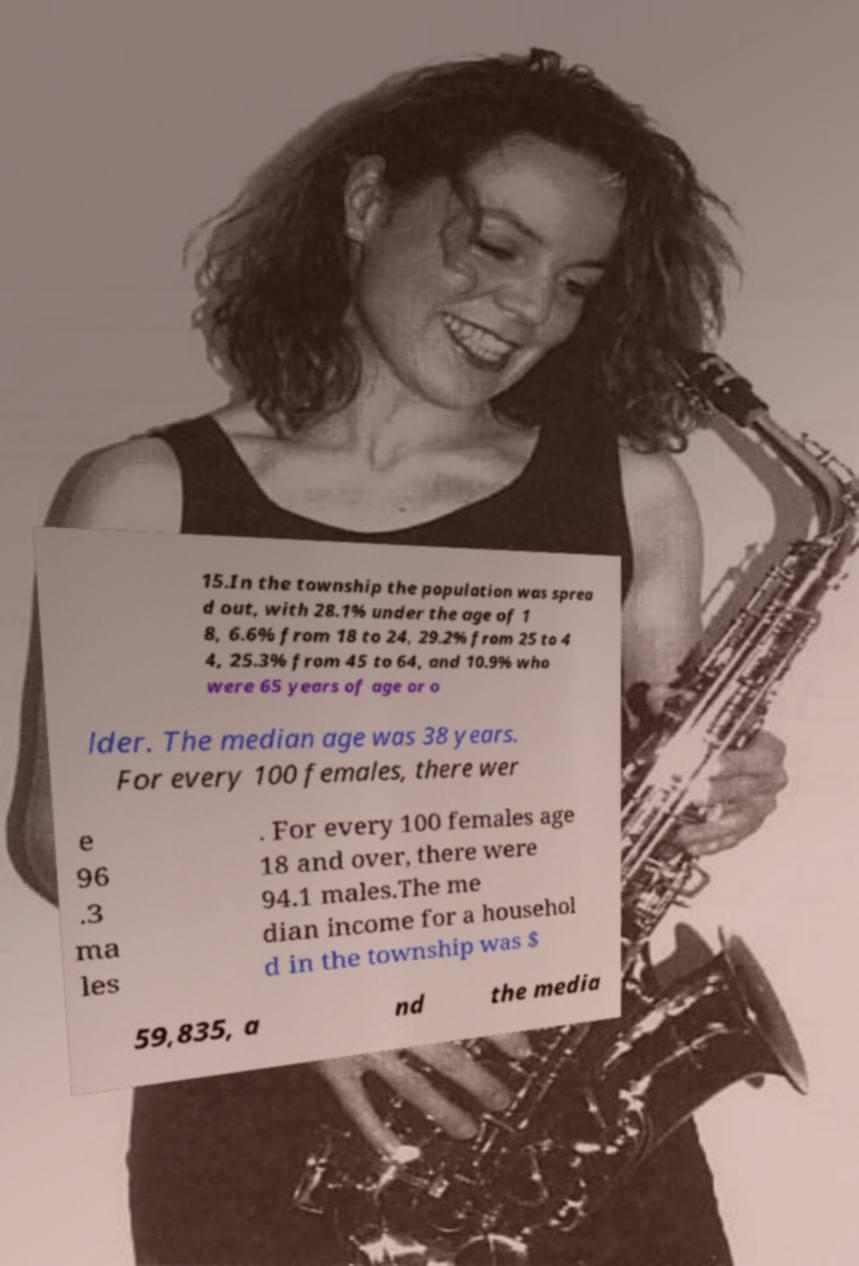Please identify and transcribe the text found in this image. 15.In the township the population was sprea d out, with 28.1% under the age of 1 8, 6.6% from 18 to 24, 29.2% from 25 to 4 4, 25.3% from 45 to 64, and 10.9% who were 65 years of age or o lder. The median age was 38 years. For every 100 females, there wer e 96 .3 ma les . For every 100 females age 18 and over, there were 94.1 males.The me dian income for a househol d in the township was $ 59,835, a nd the media 